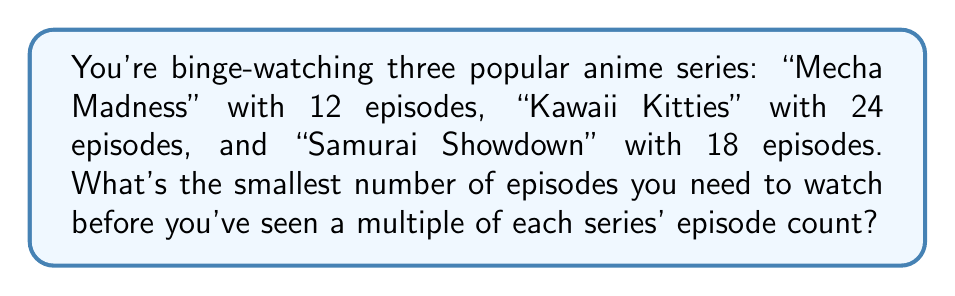Solve this math problem. To find the least common multiple (LCM) of the episode counts, we'll use the prime factorization method:

1. Prime factorize each number:
   12 = $2^2 \times 3$
   24 = $2^3 \times 3$
   18 = $2 \times 3^2$

2. Take each prime factor to the highest power it occurs in any of the numbers:
   $2^3$ (from 24)
   $3^2$ (from 18)

3. Multiply these highest powers:
   LCM = $2^3 \times 3^2 = 8 \times 9 = 72$

This means 72 is the smallest number that's divisible by 12, 24, and 18.
Answer: 72 episodes 